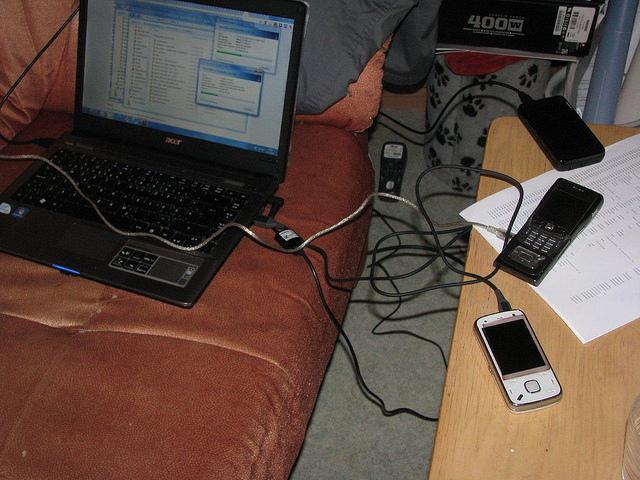How many electronics are currently charging?
Give a very brief answer. 4. How many cell phones are in the picture?
Give a very brief answer. 3. How many people are visible?
Give a very brief answer. 1. How many horses are there?
Give a very brief answer. 0. 